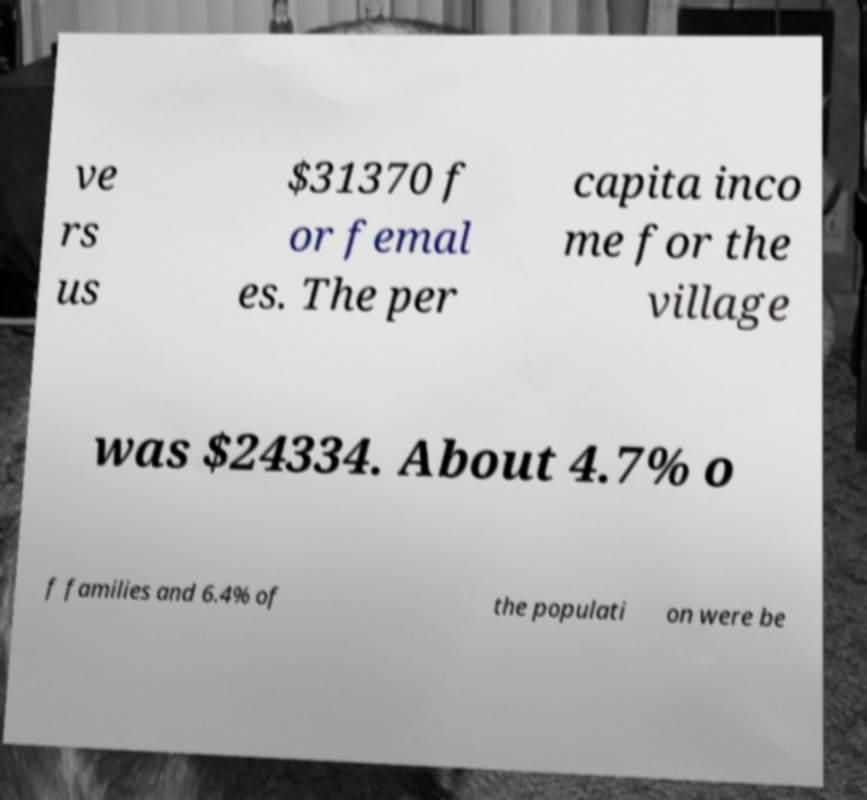Please identify and transcribe the text found in this image. ve rs us $31370 f or femal es. The per capita inco me for the village was $24334. About 4.7% o f families and 6.4% of the populati on were be 